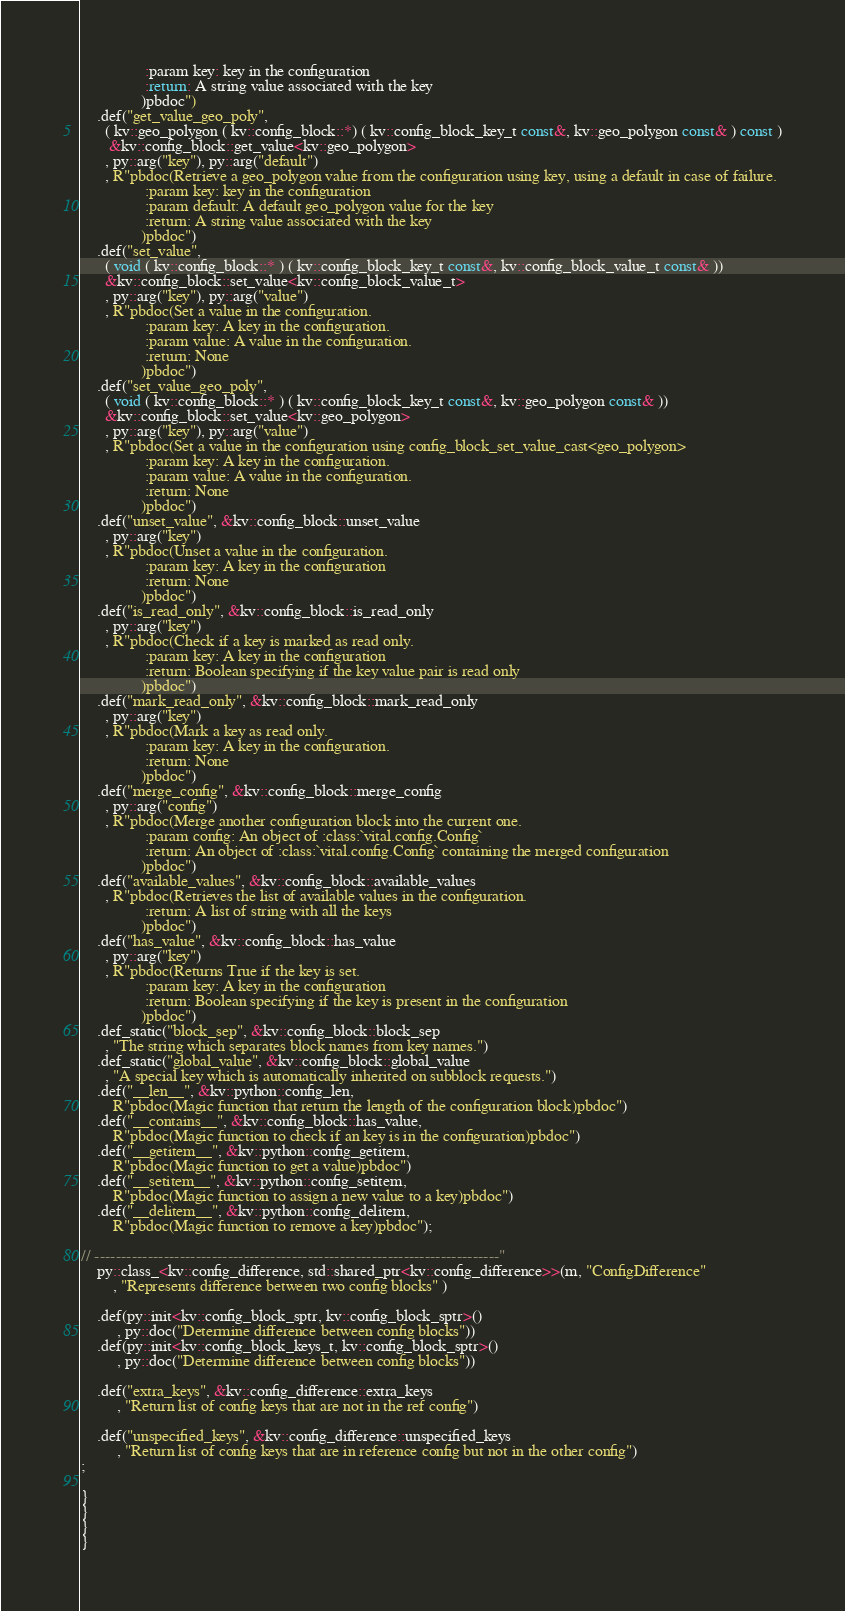<code> <loc_0><loc_0><loc_500><loc_500><_C++_>                :param key: key in the configuration
                :return: A string value associated with the key
               )pbdoc")
    .def("get_value_geo_poly",
      ( kv::geo_polygon ( kv::config_block::*) ( kv::config_block_key_t const&, kv::geo_polygon const& ) const )
       &kv::config_block::get_value<kv::geo_polygon>
      , py::arg("key"), py::arg("default")
      , R"pbdoc(Retrieve a geo_polygon value from the configuration using key, using a default in case of failure.
                :param key: key in the configuration
                :param default: A default geo_polygon value for the key
                :return: A string value associated with the key
               )pbdoc")
    .def("set_value",
      ( void ( kv::config_block::* ) ( kv::config_block_key_t const&, kv::config_block_value_t const& ))
      &kv::config_block::set_value<kv::config_block_value_t>
      , py::arg("key"), py::arg("value")
      , R"pbdoc(Set a value in the configuration.
                :param key: A key in the configuration.
                :param value: A value in the configuration.
                :return: None
               )pbdoc")
    .def("set_value_geo_poly",
      ( void ( kv::config_block::* ) ( kv::config_block_key_t const&, kv::geo_polygon const& ))
      &kv::config_block::set_value<kv::geo_polygon>
      , py::arg("key"), py::arg("value")
      , R"pbdoc(Set a value in the configuration using config_block_set_value_cast<geo_polygon>
                :param key: A key in the configuration.
                :param value: A value in the configuration.
                :return: None
               )pbdoc")
    .def("unset_value", &kv::config_block::unset_value
      , py::arg("key")
      , R"pbdoc(Unset a value in the configuration.
                :param key: A key in the configuration
                :return: None
               )pbdoc")
    .def("is_read_only", &kv::config_block::is_read_only
      , py::arg("key")
      , R"pbdoc(Check if a key is marked as read only.
                :param key: A key in the configuration
                :return: Boolean specifying if the key value pair is read only
               )pbdoc")
    .def("mark_read_only", &kv::config_block::mark_read_only
      , py::arg("key")
      , R"pbdoc(Mark a key as read only.
                :param key: A key in the configuration.
                :return: None
               )pbdoc")
    .def("merge_config", &kv::config_block::merge_config
      , py::arg("config")
      , R"pbdoc(Merge another configuration block into the current one.
                :param config: An object of :class:`vital.config.Config`
                :return: An object of :class:`vital.config.Config` containing the merged configuration
               )pbdoc")
    .def("available_values", &kv::config_block::available_values
      , R"pbdoc(Retrieves the list of available values in the configuration.
                :return: A list of string with all the keys
               )pbdoc")
    .def("has_value", &kv::config_block::has_value
      , py::arg("key")
      , R"pbdoc(Returns True if the key is set.
                :param key: A key in the configuration
                :return: Boolean specifying if the key is present in the configuration
               )pbdoc")
    .def_static("block_sep", &kv::config_block::block_sep
      , "The string which separates block names from key names.")
    .def_static("global_value", &kv::config_block::global_value
      , "A special key which is automatically inherited on subblock requests.")
    .def("__len__", &kv::python::config_len,
        R"pbdoc(Magic function that return the length of the configuration block)pbdoc")
    .def("__contains__", &kv::config_block::has_value,
        R"pbdoc(Magic function to check if an key is in the configuration)pbdoc")
    .def("__getitem__", &kv::python::config_getitem,
        R"pbdoc(Magic function to get a value)pbdoc")
    .def("__setitem__", &kv::python::config_setitem,
        R"pbdoc(Magic function to assign a new value to a key)pbdoc")
    .def("__delitem__", &kv::python::config_delitem,
        R"pbdoc(Magic function to remove a key)pbdoc");

// ----------------------------------------------------------------------------"
    py::class_<kv::config_difference, std::shared_ptr<kv::config_difference>>(m, "ConfigDifference"
        , "Represents difference between two config blocks" )

    .def(py::init<kv::config_block_sptr, kv::config_block_sptr>()
         , py::doc("Determine difference between config blocks"))
    .def(py::init<kv::config_block_keys_t, kv::config_block_sptr>()
         , py::doc("Determine difference between config blocks"))

    .def("extra_keys", &kv::config_difference::extra_keys
         , "Return list of config keys that are not in the ref config")

    .def("unspecified_keys", &kv::config_difference::unspecified_keys
         , "Return list of config keys that are in reference config but not in the other config")
;

}
}
}
}
</code> 